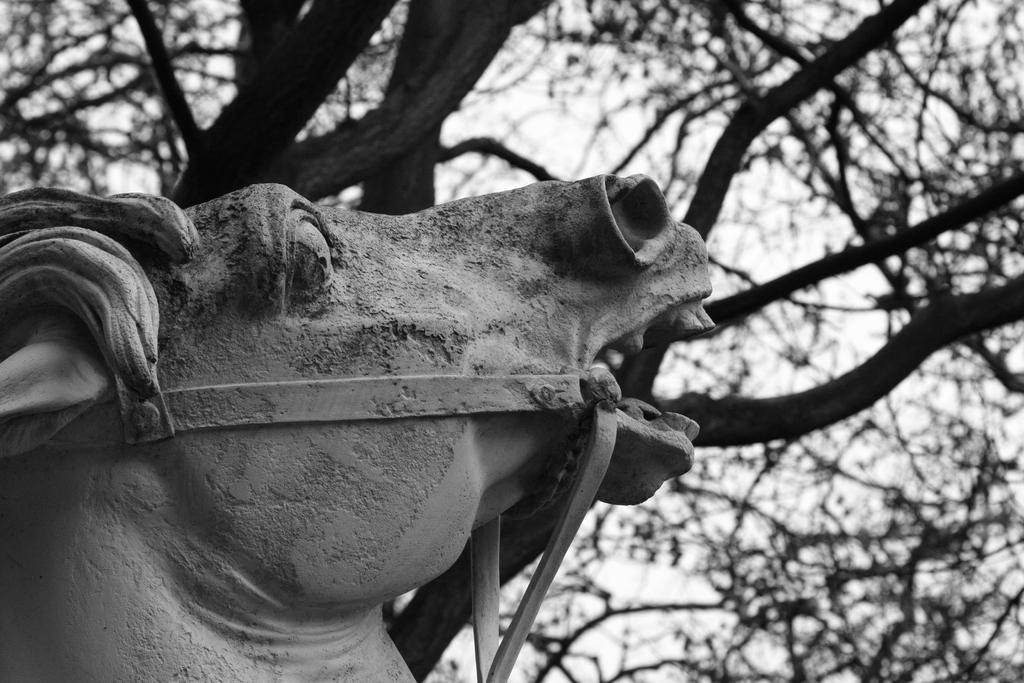What is located on the left side of the image? There is a statue of a horse on the left side of the image. What can be seen in the background of the image? There are trees in the background of the image. What is visible in the image besides the statue and trees? The sky is visible in the image. What type of basket is being used to cover the statue in the image? There is no basket or covering present on the statue in the image. 